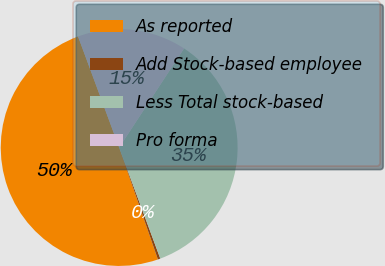<chart> <loc_0><loc_0><loc_500><loc_500><pie_chart><fcel>As reported<fcel>Add Stock-based employee<fcel>Less Total stock-based<fcel>Pro forma<nl><fcel>49.66%<fcel>0.34%<fcel>35.13%<fcel>14.87%<nl></chart> 